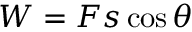<formula> <loc_0><loc_0><loc_500><loc_500>W = F s \cos { \theta }</formula> 